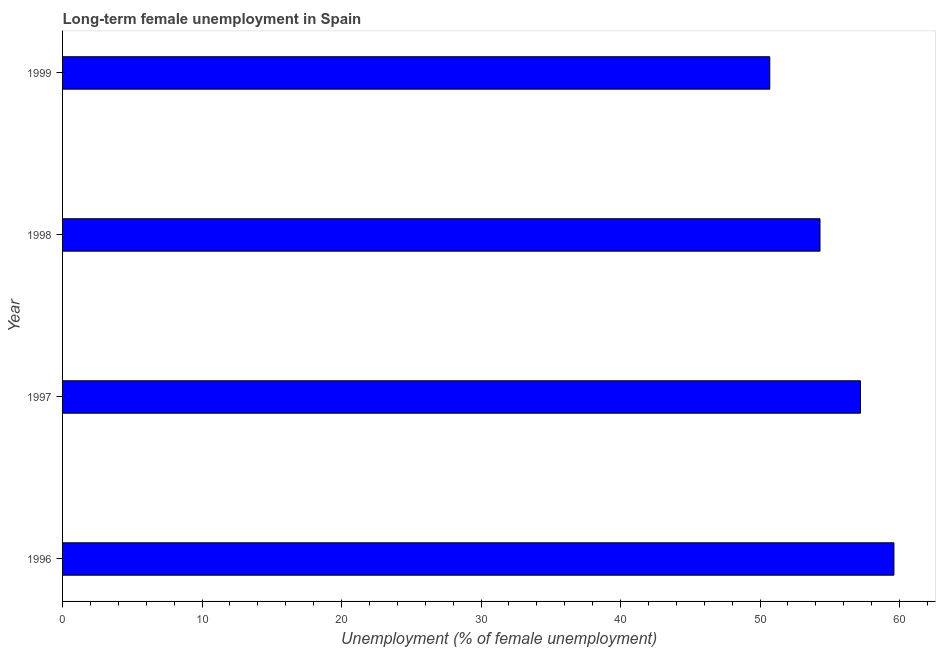Does the graph contain grids?
Your answer should be very brief. No. What is the title of the graph?
Ensure brevity in your answer.  Long-term female unemployment in Spain. What is the label or title of the X-axis?
Your answer should be compact. Unemployment (% of female unemployment). What is the label or title of the Y-axis?
Provide a succinct answer. Year. What is the long-term female unemployment in 1998?
Your answer should be compact. 54.3. Across all years, what is the maximum long-term female unemployment?
Keep it short and to the point. 59.6. Across all years, what is the minimum long-term female unemployment?
Ensure brevity in your answer.  50.7. What is the sum of the long-term female unemployment?
Ensure brevity in your answer.  221.8. What is the difference between the long-term female unemployment in 1997 and 1999?
Make the answer very short. 6.5. What is the average long-term female unemployment per year?
Provide a short and direct response. 55.45. What is the median long-term female unemployment?
Offer a terse response. 55.75. What is the ratio of the long-term female unemployment in 1996 to that in 1998?
Ensure brevity in your answer.  1.1. Is the long-term female unemployment in 1996 less than that in 1997?
Ensure brevity in your answer.  No. What is the difference between the highest and the second highest long-term female unemployment?
Offer a terse response. 2.4. In how many years, is the long-term female unemployment greater than the average long-term female unemployment taken over all years?
Make the answer very short. 2. How many years are there in the graph?
Your answer should be compact. 4. What is the difference between two consecutive major ticks on the X-axis?
Offer a terse response. 10. What is the Unemployment (% of female unemployment) of 1996?
Your response must be concise. 59.6. What is the Unemployment (% of female unemployment) of 1997?
Your answer should be very brief. 57.2. What is the Unemployment (% of female unemployment) in 1998?
Give a very brief answer. 54.3. What is the Unemployment (% of female unemployment) in 1999?
Your answer should be compact. 50.7. What is the difference between the Unemployment (% of female unemployment) in 1996 and 1999?
Ensure brevity in your answer.  8.9. What is the difference between the Unemployment (% of female unemployment) in 1997 and 1998?
Ensure brevity in your answer.  2.9. What is the difference between the Unemployment (% of female unemployment) in 1997 and 1999?
Offer a terse response. 6.5. What is the difference between the Unemployment (% of female unemployment) in 1998 and 1999?
Ensure brevity in your answer.  3.6. What is the ratio of the Unemployment (% of female unemployment) in 1996 to that in 1997?
Provide a short and direct response. 1.04. What is the ratio of the Unemployment (% of female unemployment) in 1996 to that in 1998?
Offer a very short reply. 1.1. What is the ratio of the Unemployment (% of female unemployment) in 1996 to that in 1999?
Your answer should be compact. 1.18. What is the ratio of the Unemployment (% of female unemployment) in 1997 to that in 1998?
Offer a terse response. 1.05. What is the ratio of the Unemployment (% of female unemployment) in 1997 to that in 1999?
Provide a succinct answer. 1.13. What is the ratio of the Unemployment (% of female unemployment) in 1998 to that in 1999?
Offer a very short reply. 1.07. 